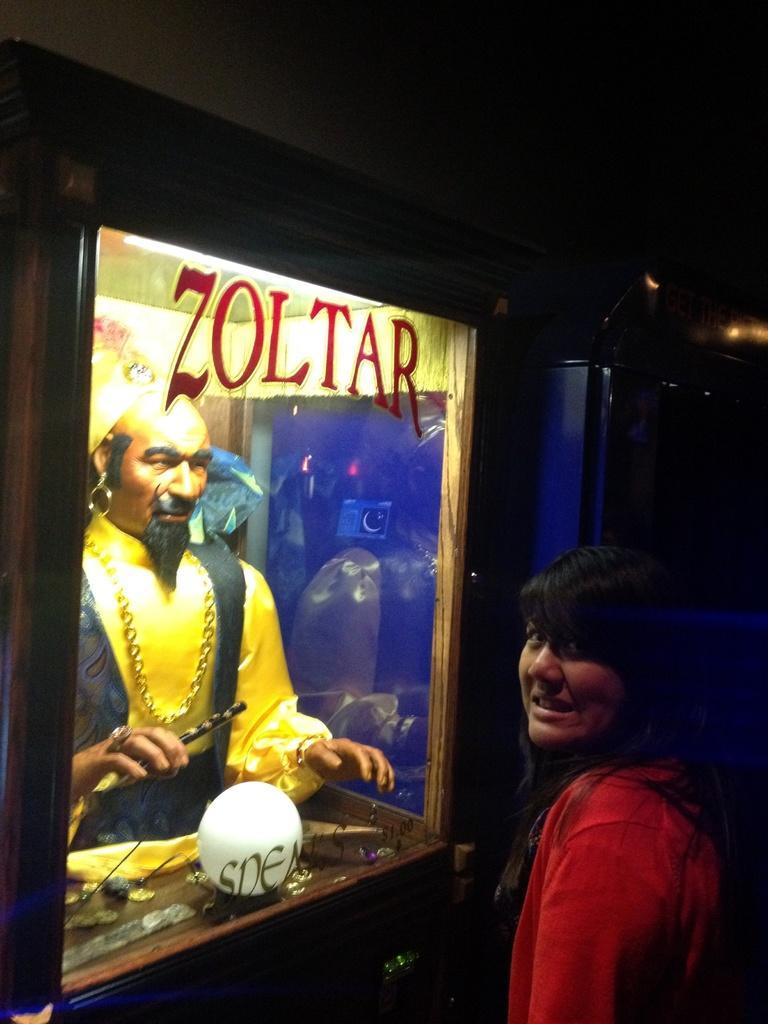In one or two sentences, can you explain what this image depicts? The picture is taken in the nighttime. In this image there is a girl on the right side. In front of her there is a statue which is kept in the glass box. In front of the statue there is a white ball. The statue is holding the stick. 